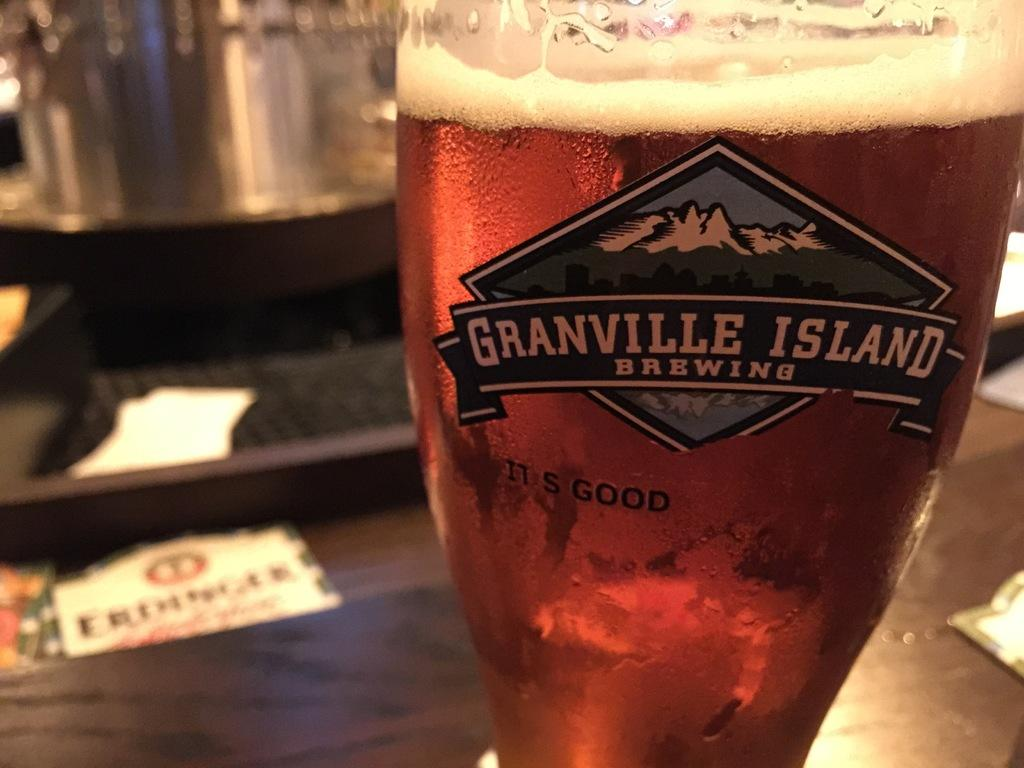<image>
Write a terse but informative summary of the picture. a glass of beer with the Granville Island on it 